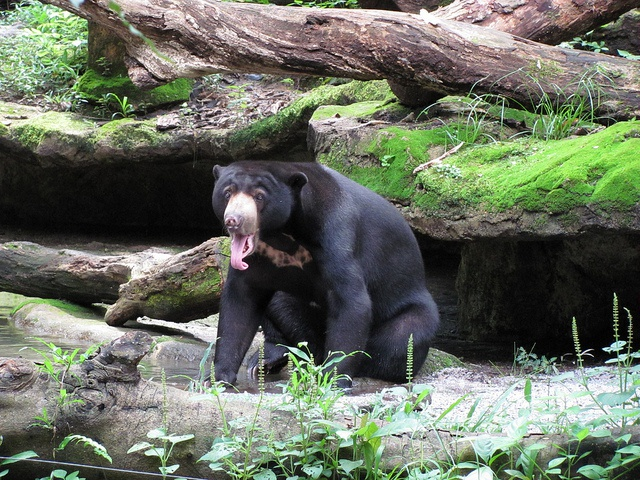Describe the objects in this image and their specific colors. I can see a bear in black, gray, and darkgray tones in this image. 